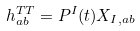<formula> <loc_0><loc_0><loc_500><loc_500>h _ { a b } ^ { T T } = P ^ { I } ( t ) X _ { I , a b }</formula> 